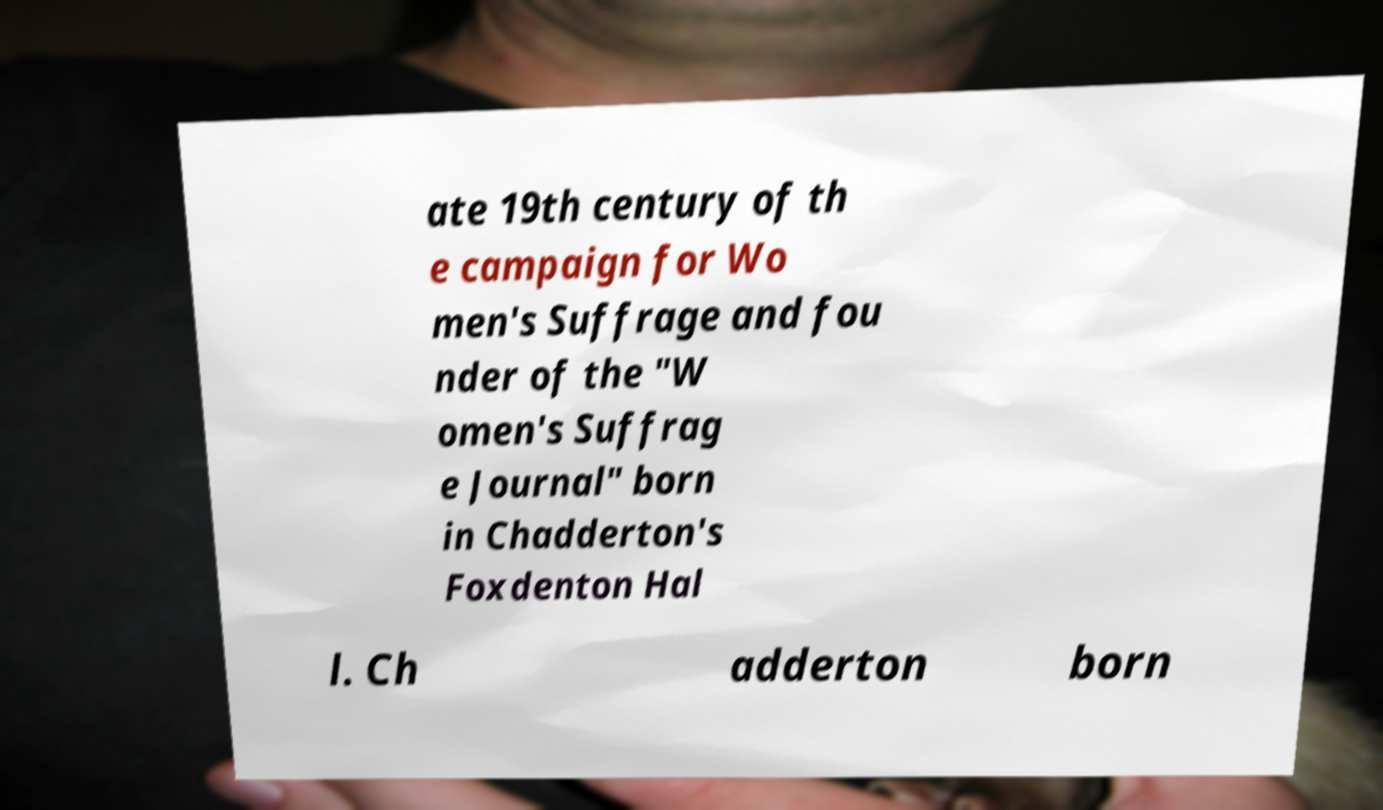I need the written content from this picture converted into text. Can you do that? ate 19th century of th e campaign for Wo men's Suffrage and fou nder of the "W omen's Suffrag e Journal" born in Chadderton's Foxdenton Hal l. Ch adderton born 